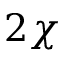Convert formula to latex. <formula><loc_0><loc_0><loc_500><loc_500>2 \chi</formula> 